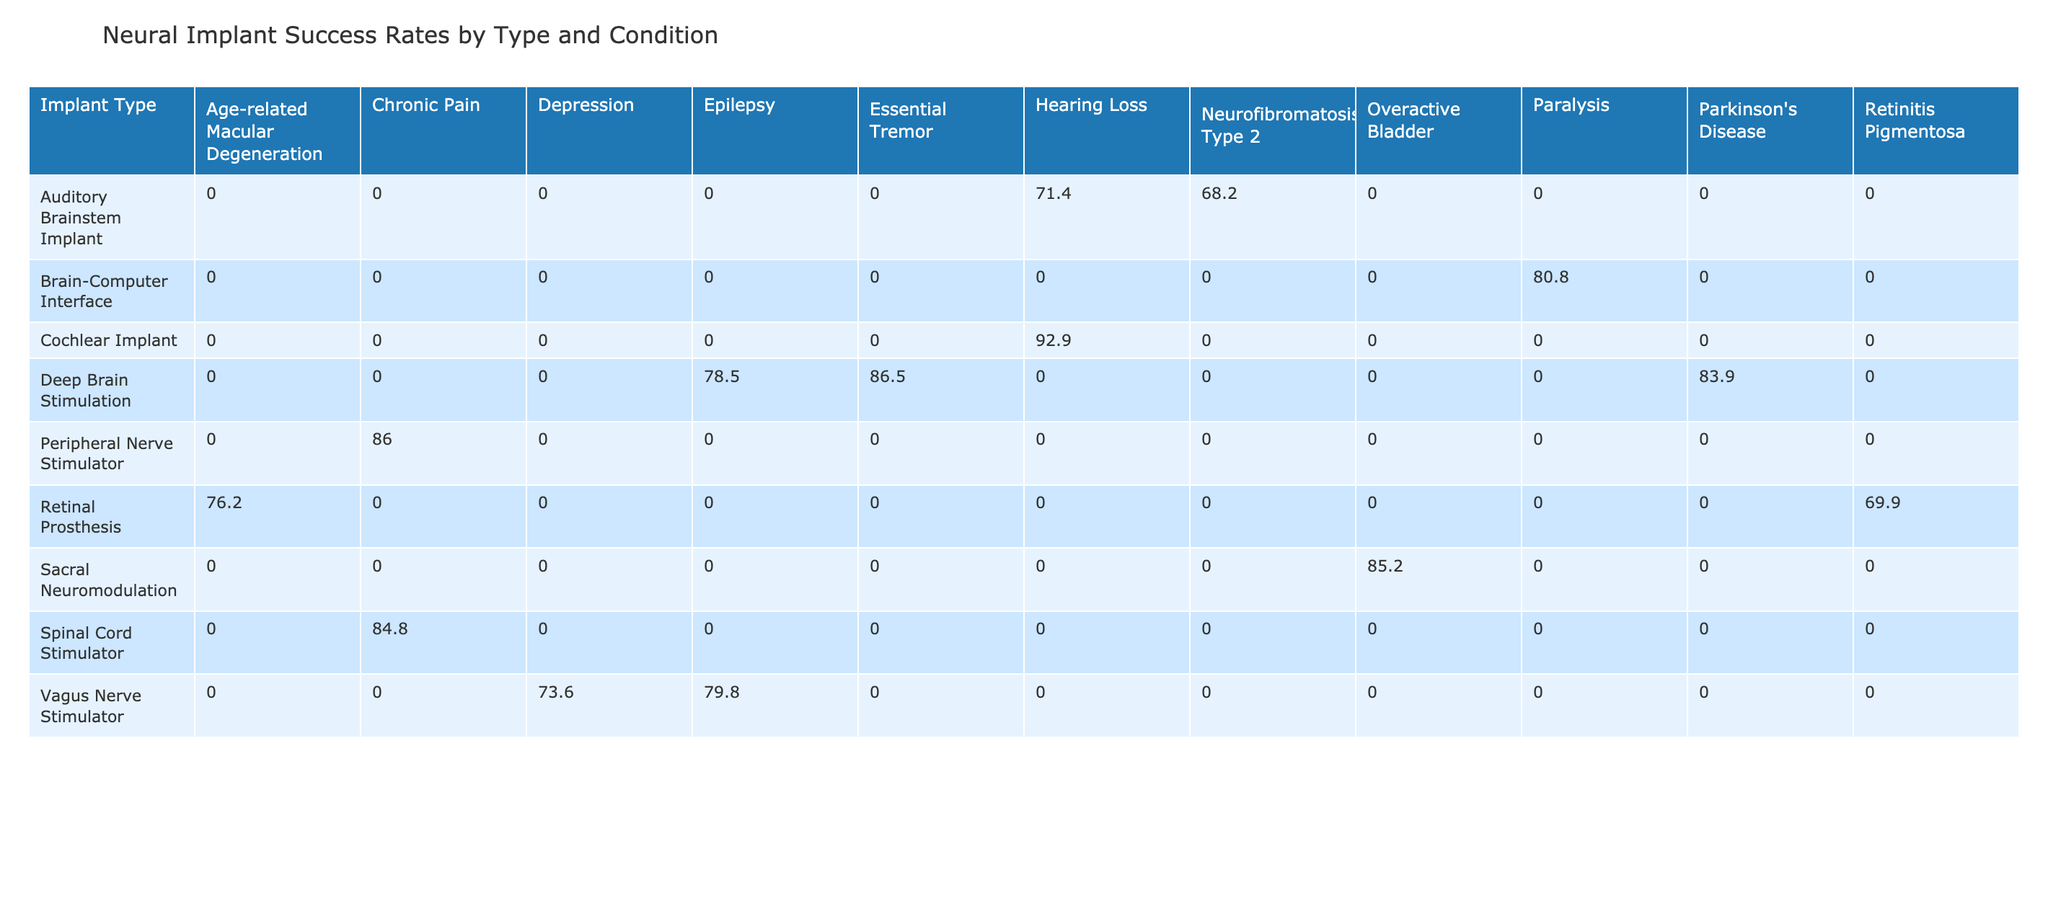What is the success rate of Deep Brain Stimulation for epilepsy? By looking at the row corresponding to Deep Brain Stimulation in the table, I can see that the success rate listed under the Primary Condition "Epilepsy" is 78.5%.
Answer: 78.5% Which implant type has the highest success rate for hearing loss? The table shows success rates for Cochlear Implant under hearing loss in two trials: SYNCHRONY 2 Trial at 92.3% and GENIUS Trial at 94.6%. The higher of the two is 94.6%.
Answer: 94.6% What is the average success rate of Spinal Cord Stimulator across its trials? The success rates for Spinal Cord Stimulator are 81.2% (Freedom SCS Trial) and 88.3% (Senza SCS Trial). The average is calculated as (81.2 + 88.3) / 2 = 84.75%.
Answer: 84.8% Is the success rate for Peripheral Nerve Stimulator higher than that of Auditory Brainstem Implant? The success rate for Peripheral Nerve Stimulator is 89.1%, while for Auditory Brainstem Implant, it is 71.4%. Since 89.1% is greater than 71.4%, the answer is yes.
Answer: Yes What is the difference in success rates between the best and worst performing neural implant for Chronic Pain? The success rates for Spinal Cord Stimulator (81.2%) and Peripheral Nerve Stimulator (89.1%) are compared. The difference is 89.1 - 81.2 = 7.9%.
Answer: 7.9% Which type of implant has the lowest success rate among all primary conditions? Looking at the table, the lowest success rate is for the Retinal Prosthesis under the condition Retinitis Pigmentosa, which is 67.8%.
Answer: 67.8% How many different types of implants have a success rate above 80%? The types of implants with success rates above 80% are: Deep Brain Stimulation (3 trials), Cochlear Implant (2 trials), Peripheral Nerve Stimulator, Sacral Neuromodulation, and Spinal Cord Stimulator. In total, there are 7 instances of implants with rates above 80%.
Answer: 7 